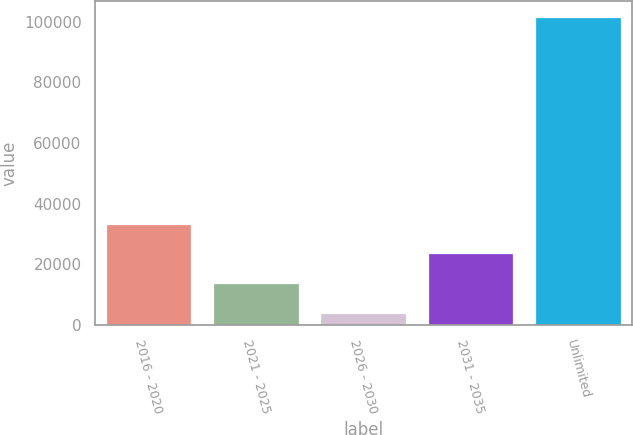Convert chart. <chart><loc_0><loc_0><loc_500><loc_500><bar_chart><fcel>2016 - 2020<fcel>2021 - 2025<fcel>2026 - 2030<fcel>2031 - 2035<fcel>Unlimited<nl><fcel>33420.3<fcel>13900.1<fcel>4140<fcel>23660.2<fcel>101741<nl></chart> 